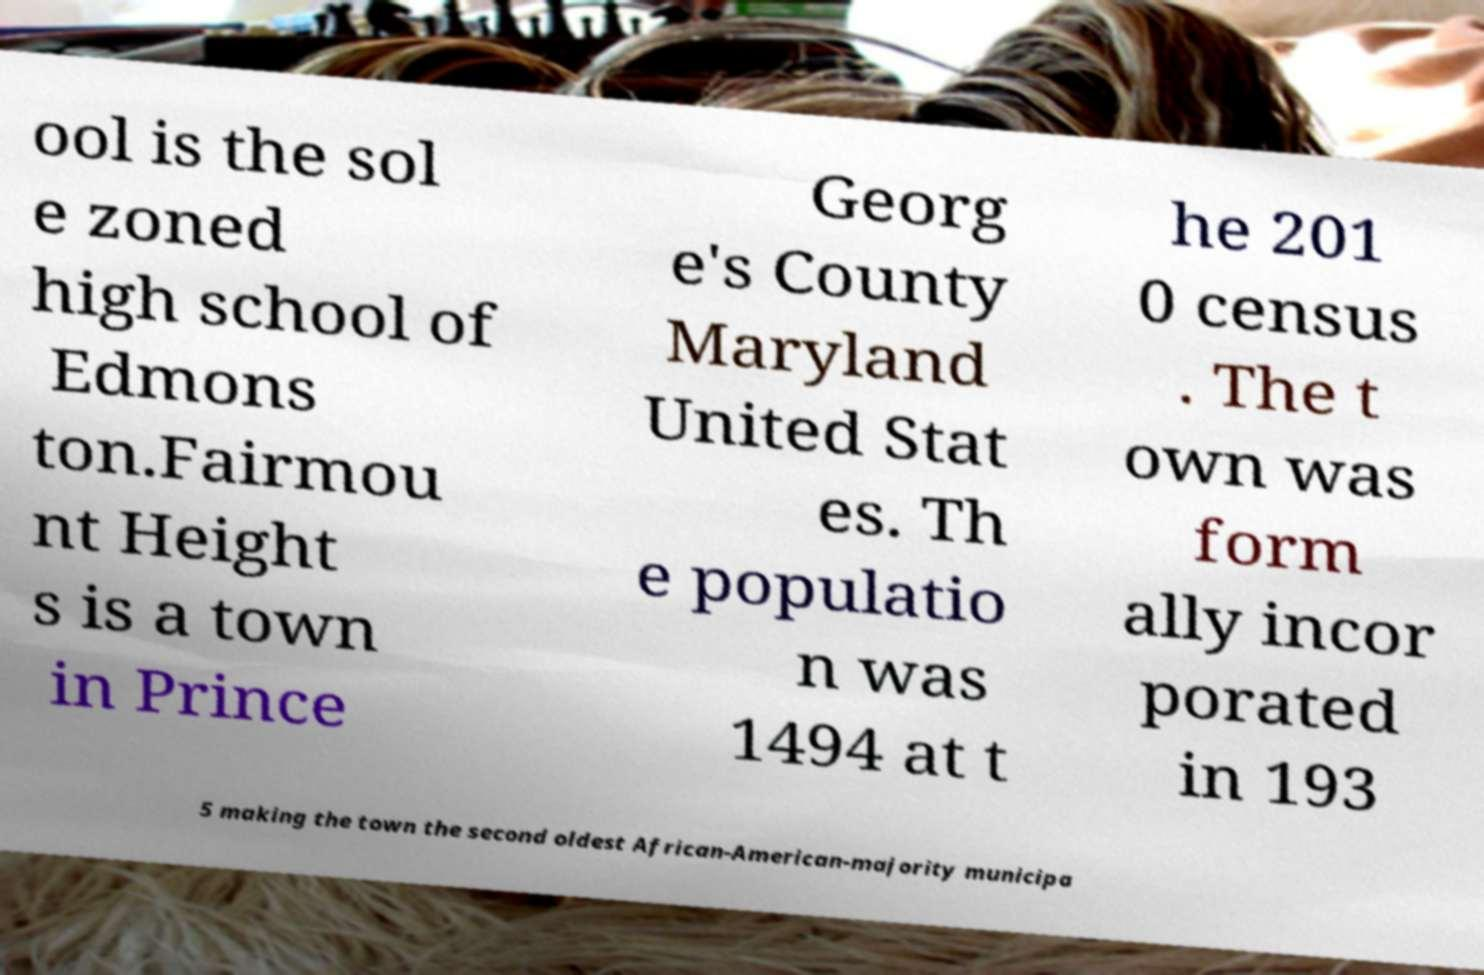Please read and relay the text visible in this image. What does it say? ool is the sol e zoned high school of Edmons ton.Fairmou nt Height s is a town in Prince Georg e's County Maryland United Stat es. Th e populatio n was 1494 at t he 201 0 census . The t own was form ally incor porated in 193 5 making the town the second oldest African-American-majority municipa 